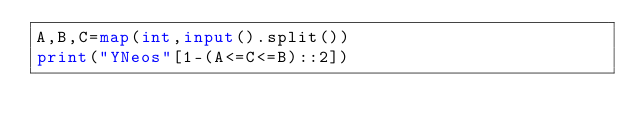Convert code to text. <code><loc_0><loc_0><loc_500><loc_500><_Python_>A,B,C=map(int,input().split())
print("YNeos"[1-(A<=C<=B)::2])</code> 